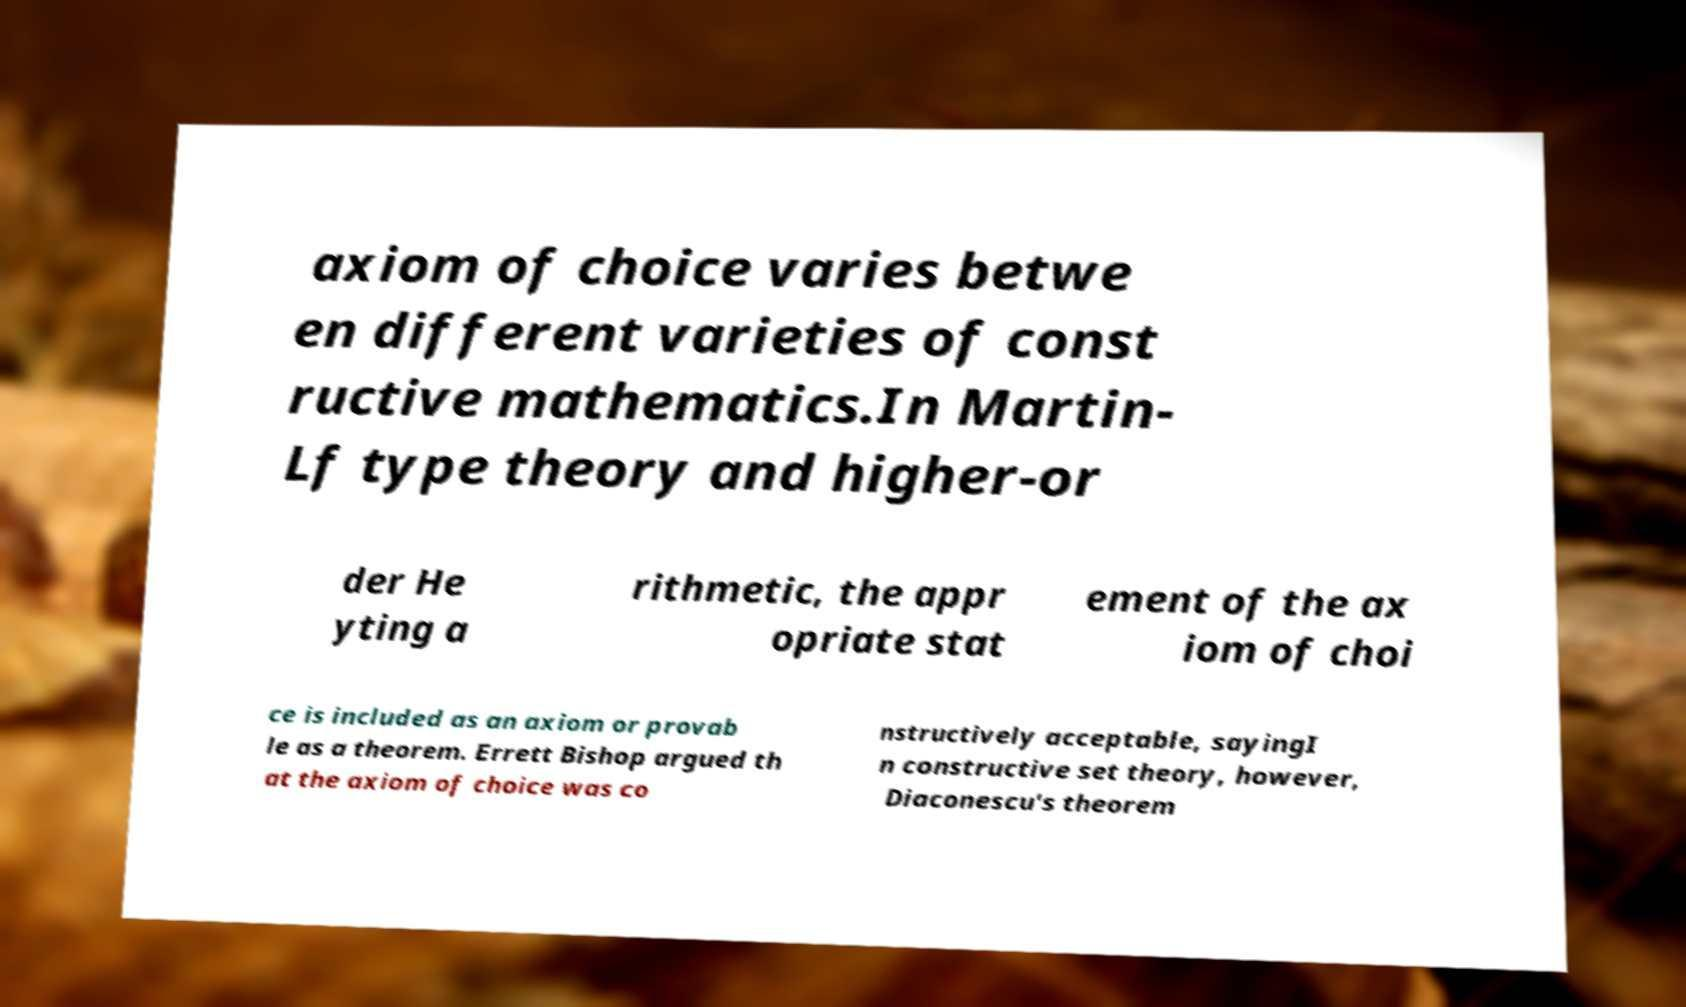What messages or text are displayed in this image? I need them in a readable, typed format. axiom of choice varies betwe en different varieties of const ructive mathematics.In Martin- Lf type theory and higher-or der He yting a rithmetic, the appr opriate stat ement of the ax iom of choi ce is included as an axiom or provab le as a theorem. Errett Bishop argued th at the axiom of choice was co nstructively acceptable, sayingI n constructive set theory, however, Diaconescu's theorem 